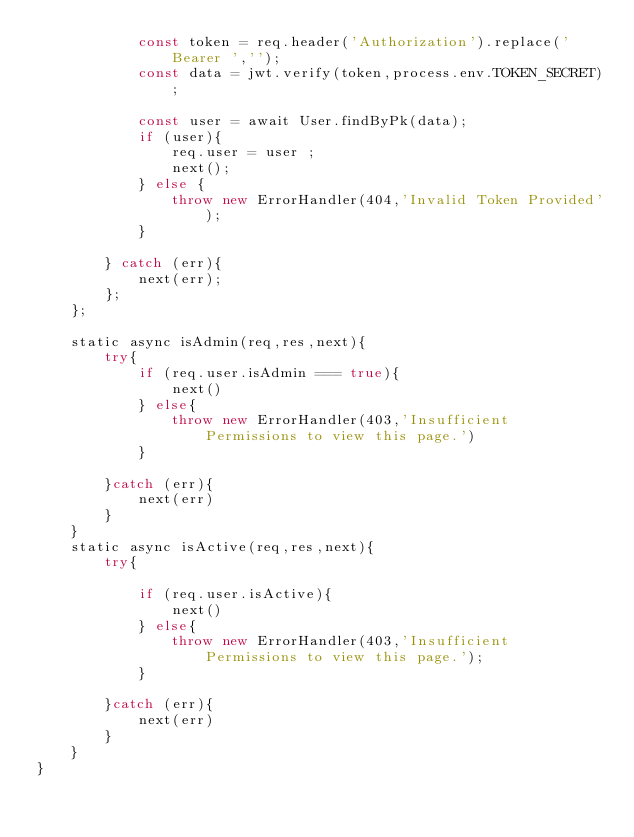Convert code to text. <code><loc_0><loc_0><loc_500><loc_500><_JavaScript_>            const token = req.header('Authorization').replace('Bearer ','');
            const data = jwt.verify(token,process.env.TOKEN_SECRET);

            const user = await User.findByPk(data);
            if (user){
                req.user = user ;
                next();
            } else {
                throw new ErrorHandler(404,'Invalid Token Provided');
            }
            
        } catch (err){
            next(err);
        };
    };

    static async isAdmin(req,res,next){
        try{
            if (req.user.isAdmin === true){
                next()
            } else{
                throw new ErrorHandler(403,'Insufficient Permissions to view this page.')
            }
            
        }catch (err){
            next(err)
        }
    }
    static async isActive(req,res,next){
        try{

            if (req.user.isActive){
                next()
            } else{
                throw new ErrorHandler(403,'Insufficient Permissions to view this page.');
            }
            
        }catch (err){
            next(err)
        }
    }
}</code> 